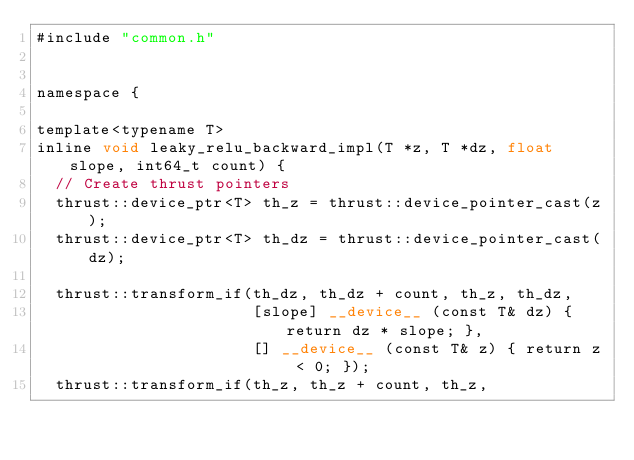Convert code to text. <code><loc_0><loc_0><loc_500><loc_500><_Cuda_>#include "common.h"


namespace {

template<typename T>
inline void leaky_relu_backward_impl(T *z, T *dz, float slope, int64_t count) {
  // Create thrust pointers
  thrust::device_ptr<T> th_z = thrust::device_pointer_cast(z);
  thrust::device_ptr<T> th_dz = thrust::device_pointer_cast(dz);

  thrust::transform_if(th_dz, th_dz + count, th_z, th_dz,
                       [slope] __device__ (const T& dz) { return dz * slope; },
                       [] __device__ (const T& z) { return z < 0; });
  thrust::transform_if(th_z, th_z + count, th_z,</code> 